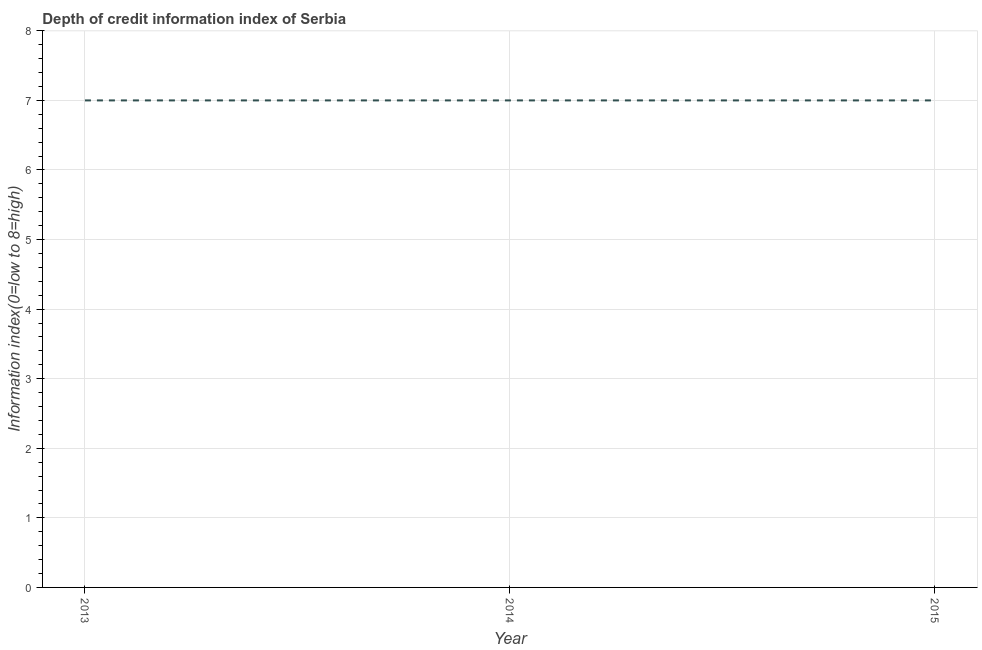What is the depth of credit information index in 2013?
Offer a very short reply. 7. Across all years, what is the maximum depth of credit information index?
Give a very brief answer. 7. Across all years, what is the minimum depth of credit information index?
Your answer should be compact. 7. In which year was the depth of credit information index minimum?
Your answer should be compact. 2013. What is the sum of the depth of credit information index?
Ensure brevity in your answer.  21. What is the median depth of credit information index?
Your answer should be very brief. 7. Do a majority of the years between 2015 and 2014 (inclusive) have depth of credit information index greater than 3 ?
Offer a terse response. No. Is the depth of credit information index in 2013 less than that in 2014?
Your answer should be compact. No. What is the difference between the highest and the second highest depth of credit information index?
Keep it short and to the point. 0. Is the sum of the depth of credit information index in 2014 and 2015 greater than the maximum depth of credit information index across all years?
Give a very brief answer. Yes. What is the difference between the highest and the lowest depth of credit information index?
Keep it short and to the point. 0. In how many years, is the depth of credit information index greater than the average depth of credit information index taken over all years?
Give a very brief answer. 0. Does the depth of credit information index monotonically increase over the years?
Your answer should be very brief. No. Are the values on the major ticks of Y-axis written in scientific E-notation?
Provide a succinct answer. No. What is the title of the graph?
Provide a succinct answer. Depth of credit information index of Serbia. What is the label or title of the Y-axis?
Keep it short and to the point. Information index(0=low to 8=high). What is the Information index(0=low to 8=high) in 2013?
Give a very brief answer. 7. What is the Information index(0=low to 8=high) in 2014?
Provide a short and direct response. 7. What is the Information index(0=low to 8=high) in 2015?
Your answer should be very brief. 7. What is the difference between the Information index(0=low to 8=high) in 2013 and 2015?
Ensure brevity in your answer.  0. What is the difference between the Information index(0=low to 8=high) in 2014 and 2015?
Give a very brief answer. 0. What is the ratio of the Information index(0=low to 8=high) in 2013 to that in 2014?
Your response must be concise. 1. 